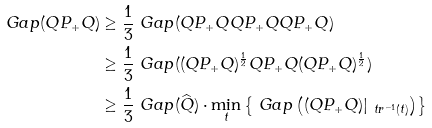<formula> <loc_0><loc_0><loc_500><loc_500>\ G a p ( Q P _ { + } Q ) & \geq \frac { 1 } { 3 } \ G a p ( Q P _ { + } Q Q P _ { + } Q Q P _ { + } Q ) \\ & \geq \frac { 1 } { 3 } \ G a p ( ( Q P _ { + } Q ) ^ { \frac { 1 } { 2 } } Q P _ { + } Q ( Q P _ { + } Q ) ^ { \frac { 1 } { 2 } } ) \\ & \geq \frac { 1 } { 3 } \ G a p ( \widehat { Q } ) \cdot \min _ { t } \left \{ \ G a p \left ( ( Q P _ { + } Q ) | _ { \ t r ^ { - 1 } ( t ) } \right ) \right \}</formula> 